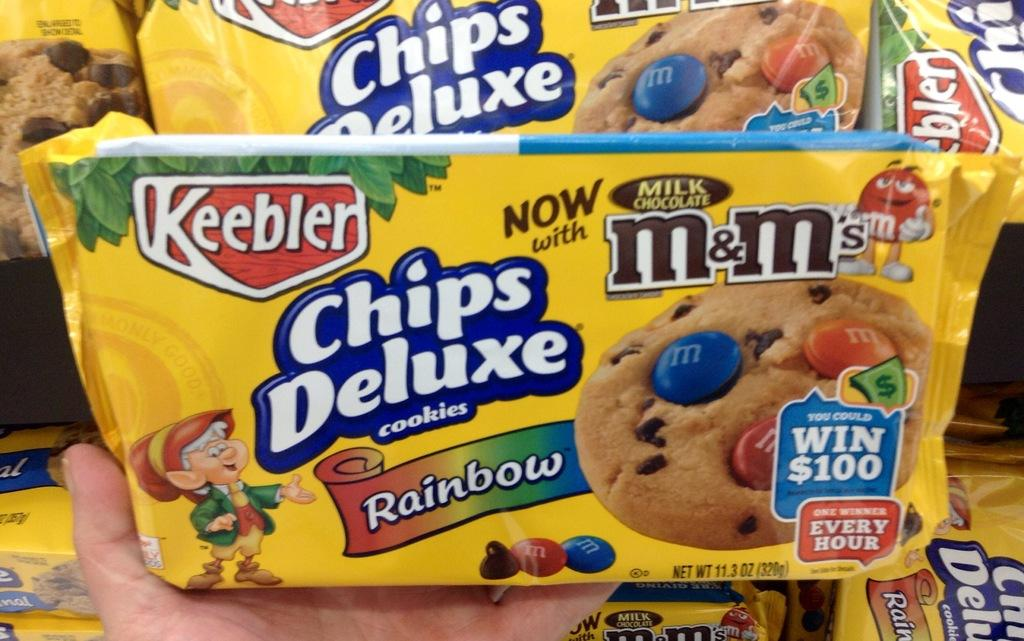What objects are present in the image? There are packets in the image. What is the color of the packets? The packets are yellow in color. What is written on the packets? There is text written on the packets. What can be seen in relation to the packets? There is a hand holding a packet in the image. How many beds are visible in the image? There are no beds present in the image. What type of base is supporting the packets? The packets are not resting on a base; they are being held by a hand. 